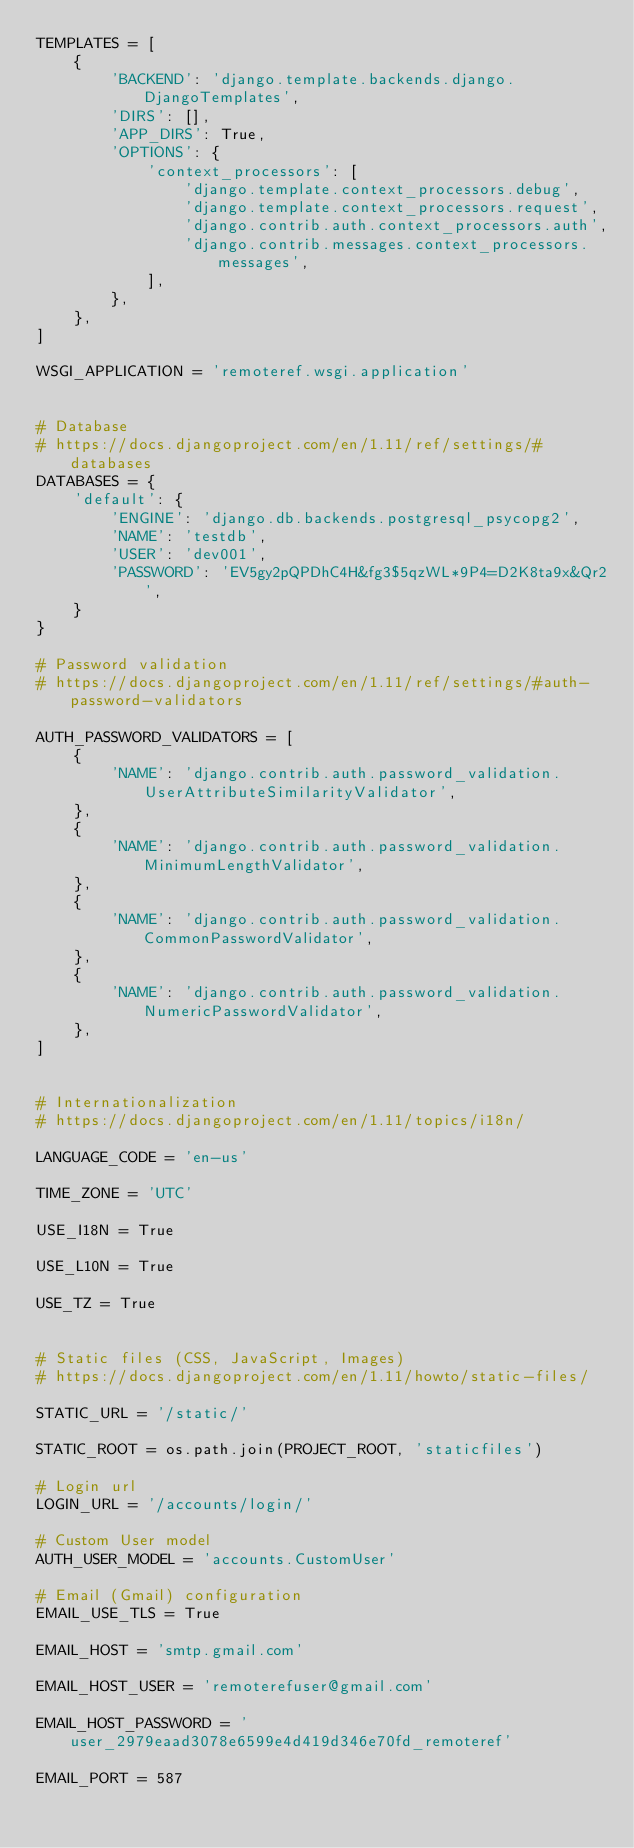<code> <loc_0><loc_0><loc_500><loc_500><_Python_>TEMPLATES = [
    {
        'BACKEND': 'django.template.backends.django.DjangoTemplates',
        'DIRS': [],
        'APP_DIRS': True,
        'OPTIONS': {
            'context_processors': [
                'django.template.context_processors.debug',
                'django.template.context_processors.request',
                'django.contrib.auth.context_processors.auth',
                'django.contrib.messages.context_processors.messages',
            ],
        },
    },
]

WSGI_APPLICATION = 'remoteref.wsgi.application'


# Database
# https://docs.djangoproject.com/en/1.11/ref/settings/#databases
DATABASES = {
    'default': {
        'ENGINE': 'django.db.backends.postgresql_psycopg2',
        'NAME': 'testdb',
        'USER': 'dev001',
        'PASSWORD': 'EV5gy2pQPDhC4H&fg3$5qzWL*9P4=D2K8ta9x&Qr2',
    }
}

# Password validation
# https://docs.djangoproject.com/en/1.11/ref/settings/#auth-password-validators

AUTH_PASSWORD_VALIDATORS = [
    {
        'NAME': 'django.contrib.auth.password_validation.UserAttributeSimilarityValidator',
    },
    {
        'NAME': 'django.contrib.auth.password_validation.MinimumLengthValidator',
    },
    {
        'NAME': 'django.contrib.auth.password_validation.CommonPasswordValidator',
    },
    {
        'NAME': 'django.contrib.auth.password_validation.NumericPasswordValidator',
    },
]


# Internationalization
# https://docs.djangoproject.com/en/1.11/topics/i18n/

LANGUAGE_CODE = 'en-us'

TIME_ZONE = 'UTC'

USE_I18N = True

USE_L10N = True

USE_TZ = True


# Static files (CSS, JavaScript, Images)
# https://docs.djangoproject.com/en/1.11/howto/static-files/

STATIC_URL = '/static/'

STATIC_ROOT = os.path.join(PROJECT_ROOT, 'staticfiles')

# Login url
LOGIN_URL = '/accounts/login/'

# Custom User model
AUTH_USER_MODEL = 'accounts.CustomUser'

# Email (Gmail) configuration
EMAIL_USE_TLS = True

EMAIL_HOST = 'smtp.gmail.com'

EMAIL_HOST_USER = 'remoterefuser@gmail.com'

EMAIL_HOST_PASSWORD = 'user_2979eaad3078e6599e4d419d346e70fd_remoteref'

EMAIL_PORT = 587
</code> 